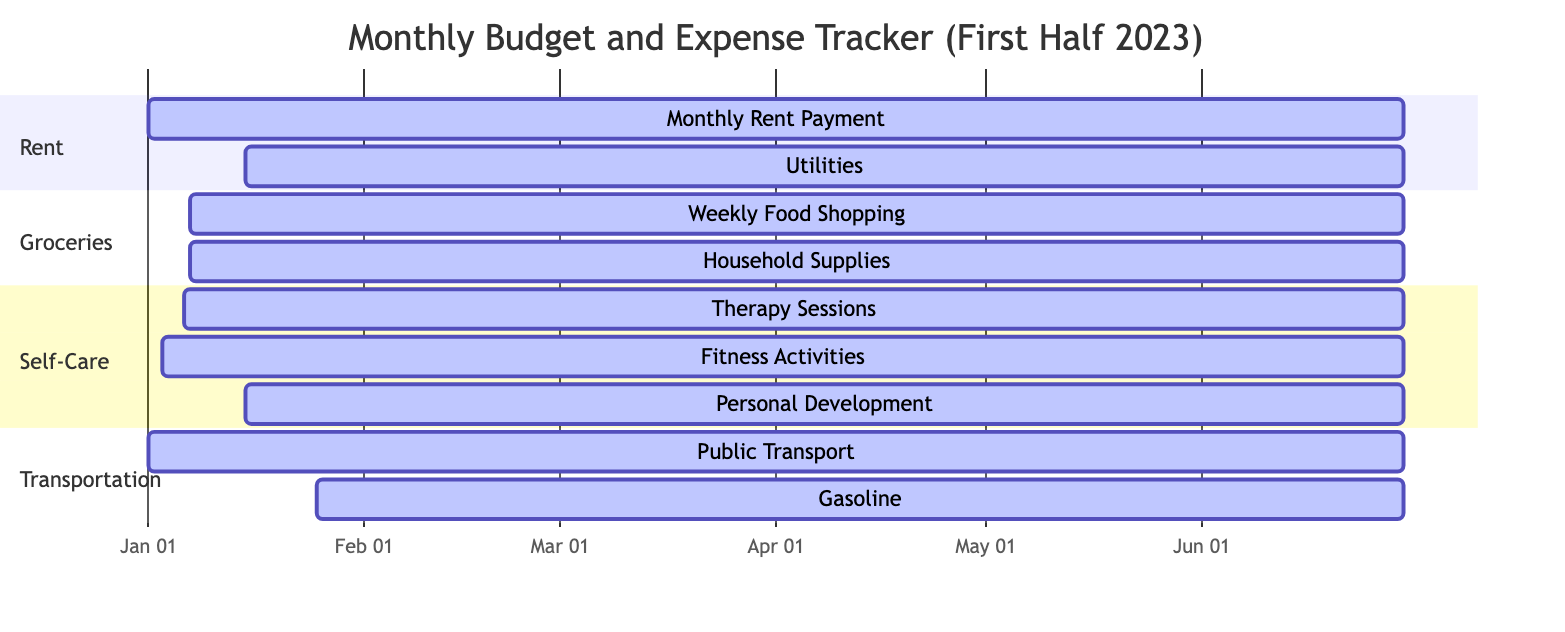What is the estimated cost for monthly rent payment? The diagram provides a description of the "Monthly Rent Payment" subcategory under the "Rent" section, which states the estimated cost is 1200.
Answer: 1200 How many categories are present in the diagram? There are four main categories listed: Rent, Groceries, Self-Care, and Transportation. This can be counted directly from the categories section in the diagram.
Answer: 4 Which self-care activity has a due date on the 15th of the month? Looking at the "Self-Care" section, the "Personal Development" subcategory specifies a due date as the fifteenth of the month.
Answer: Personal Development What are the due dates for utilities payments? The "Utilities" under the "Rent" category has a due date stated as the fifteenth of the month, which can be found in its description.
Answer: 15th of the month Which category has the highest estimated cost for a single payment? The diagram shows the "Monthly Rent Payment" under "Rent" as having an estimated cost of 1200, which is higher than any other listed costs.
Answer: Rent How many subcategories are listed under Self-Care? The "Self-Care" category includes three subcategories: Therapy Sessions, Fitness Activities, and Personal Development. This can be confirmed by counting the listed items under this category.
Answer: 3 What is the earliest due date for expenses in the diagram? Among all the listed due dates, the "Monthly Rent Payment" and "Public Transport" expenses are both due on the first of the month, which is the earliest in the timeline.
Answer: First of the month Which activity requires a weekly commitment? The "Therapy Sessions" subcategory clearly states it is scheduled for "Every Friday," implying a weekly commitment.
Answer: Therapy Sessions 